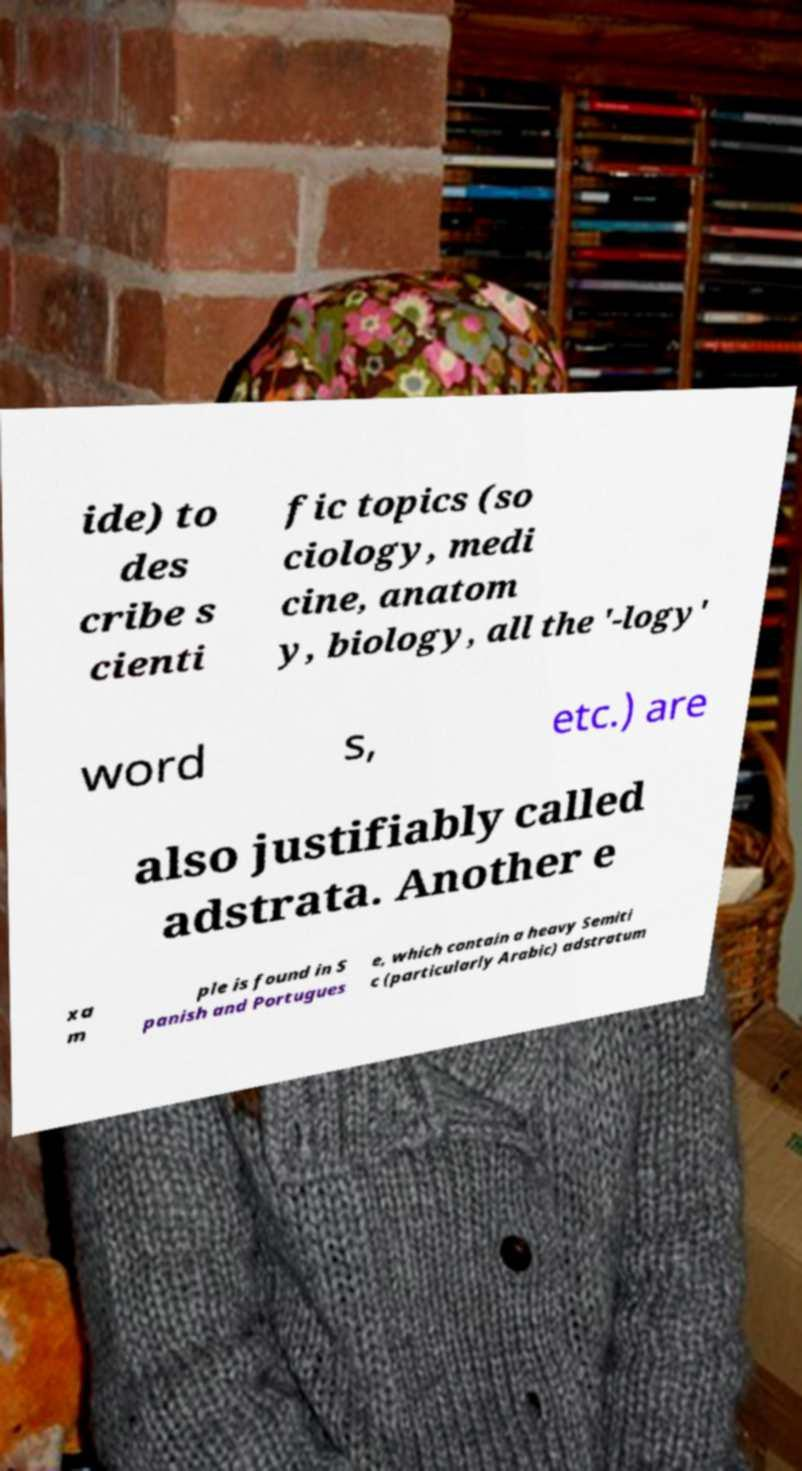Can you read and provide the text displayed in the image?This photo seems to have some interesting text. Can you extract and type it out for me? ide) to des cribe s cienti fic topics (so ciology, medi cine, anatom y, biology, all the '-logy' word s, etc.) are also justifiably called adstrata. Another e xa m ple is found in S panish and Portugues e, which contain a heavy Semiti c (particularly Arabic) adstratum 